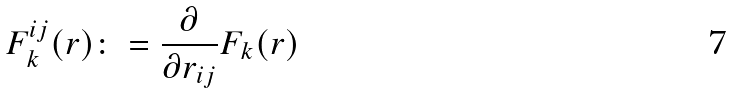Convert formula to latex. <formula><loc_0><loc_0><loc_500><loc_500>F _ { k } ^ { i j } ( r ) \colon = \frac { \partial } { \partial r _ { i j } } F _ { k } ( r )</formula> 